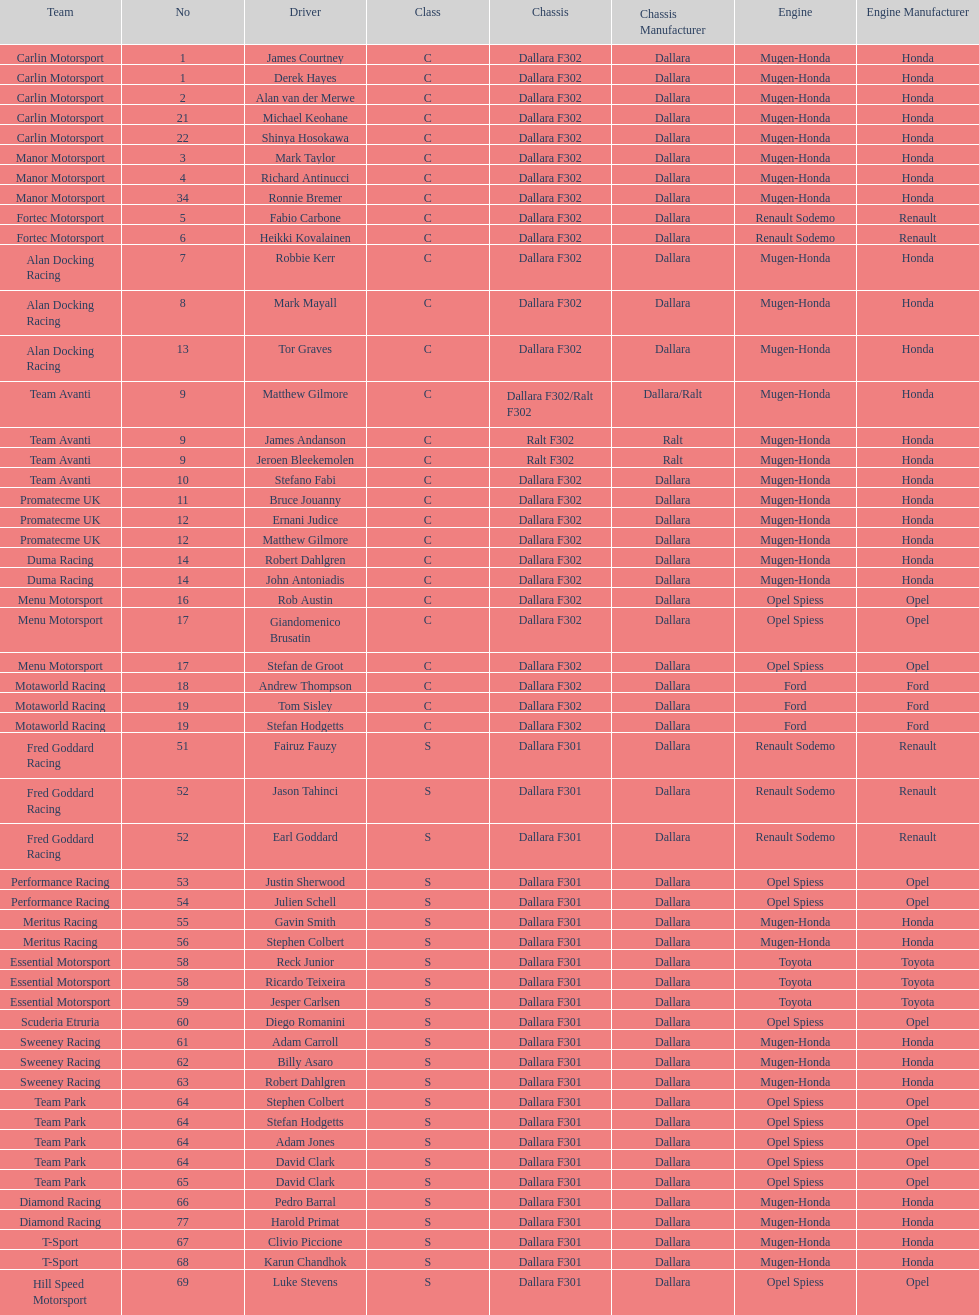What is the number of teams that had drivers all from the same country? 4. Would you mind parsing the complete table? {'header': ['Team', 'No', 'Driver', 'Class', 'Chassis', 'Chassis Manufacturer', 'Engine', 'Engine Manufacturer'], 'rows': [['Carlin Motorsport', '1', 'James Courtney', 'C', 'Dallara F302', 'Dallara', 'Mugen-Honda', 'Honda'], ['Carlin Motorsport', '1', 'Derek Hayes', 'C', 'Dallara F302', 'Dallara', 'Mugen-Honda', 'Honda'], ['Carlin Motorsport', '2', 'Alan van der Merwe', 'C', 'Dallara F302', 'Dallara', 'Mugen-Honda', 'Honda'], ['Carlin Motorsport', '21', 'Michael Keohane', 'C', 'Dallara F302', 'Dallara', 'Mugen-Honda', 'Honda'], ['Carlin Motorsport', '22', 'Shinya Hosokawa', 'C', 'Dallara F302', 'Dallara', 'Mugen-Honda', 'Honda'], ['Manor Motorsport', '3', 'Mark Taylor', 'C', 'Dallara F302', 'Dallara', 'Mugen-Honda', 'Honda'], ['Manor Motorsport', '4', 'Richard Antinucci', 'C', 'Dallara F302', 'Dallara', 'Mugen-Honda', 'Honda'], ['Manor Motorsport', '34', 'Ronnie Bremer', 'C', 'Dallara F302', 'Dallara', 'Mugen-Honda', 'Honda'], ['Fortec Motorsport', '5', 'Fabio Carbone', 'C', 'Dallara F302', 'Dallara', 'Renault Sodemo', 'Renault'], ['Fortec Motorsport', '6', 'Heikki Kovalainen', 'C', 'Dallara F302', 'Dallara', 'Renault Sodemo', 'Renault'], ['Alan Docking Racing', '7', 'Robbie Kerr', 'C', 'Dallara F302', 'Dallara', 'Mugen-Honda', 'Honda'], ['Alan Docking Racing', '8', 'Mark Mayall', 'C', 'Dallara F302', 'Dallara', 'Mugen-Honda', 'Honda'], ['Alan Docking Racing', '13', 'Tor Graves', 'C', 'Dallara F302', 'Dallara', 'Mugen-Honda', 'Honda'], ['Team Avanti', '9', 'Matthew Gilmore', 'C', 'Dallara F302/Ralt F302', 'Dallara/Ralt', 'Mugen-Honda', 'Honda'], ['Team Avanti', '9', 'James Andanson', 'C', 'Ralt F302', 'Ralt', 'Mugen-Honda', 'Honda'], ['Team Avanti', '9', 'Jeroen Bleekemolen', 'C', 'Ralt F302', 'Ralt', 'Mugen-Honda', 'Honda'], ['Team Avanti', '10', 'Stefano Fabi', 'C', 'Dallara F302', 'Dallara', 'Mugen-Honda', 'Honda'], ['Promatecme UK', '11', 'Bruce Jouanny', 'C', 'Dallara F302', 'Dallara', 'Mugen-Honda', 'Honda'], ['Promatecme UK', '12', 'Ernani Judice', 'C', 'Dallara F302', 'Dallara', 'Mugen-Honda', 'Honda'], ['Promatecme UK', '12', 'Matthew Gilmore', 'C', 'Dallara F302', 'Dallara', 'Mugen-Honda', 'Honda'], ['Duma Racing', '14', 'Robert Dahlgren', 'C', 'Dallara F302', 'Dallara', 'Mugen-Honda', 'Honda'], ['Duma Racing', '14', 'John Antoniadis', 'C', 'Dallara F302', 'Dallara', 'Mugen-Honda', 'Honda'], ['Menu Motorsport', '16', 'Rob Austin', 'C', 'Dallara F302', 'Dallara', 'Opel Spiess', 'Opel'], ['Menu Motorsport', '17', 'Giandomenico Brusatin', 'C', 'Dallara F302', 'Dallara', 'Opel Spiess', 'Opel'], ['Menu Motorsport', '17', 'Stefan de Groot', 'C', 'Dallara F302', 'Dallara', 'Opel Spiess', 'Opel'], ['Motaworld Racing', '18', 'Andrew Thompson', 'C', 'Dallara F302', 'Dallara', 'Ford', 'Ford'], ['Motaworld Racing', '19', 'Tom Sisley', 'C', 'Dallara F302', 'Dallara', 'Ford', 'Ford'], ['Motaworld Racing', '19', 'Stefan Hodgetts', 'C', 'Dallara F302', 'Dallara', 'Ford', 'Ford'], ['Fred Goddard Racing', '51', 'Fairuz Fauzy', 'S', 'Dallara F301', 'Dallara', 'Renault Sodemo', 'Renault'], ['Fred Goddard Racing', '52', 'Jason Tahinci', 'S', 'Dallara F301', 'Dallara', 'Renault Sodemo', 'Renault'], ['Fred Goddard Racing', '52', 'Earl Goddard', 'S', 'Dallara F301', 'Dallara', 'Renault Sodemo', 'Renault'], ['Performance Racing', '53', 'Justin Sherwood', 'S', 'Dallara F301', 'Dallara', 'Opel Spiess', 'Opel'], ['Performance Racing', '54', 'Julien Schell', 'S', 'Dallara F301', 'Dallara', 'Opel Spiess', 'Opel'], ['Meritus Racing', '55', 'Gavin Smith', 'S', 'Dallara F301', 'Dallara', 'Mugen-Honda', 'Honda'], ['Meritus Racing', '56', 'Stephen Colbert', 'S', 'Dallara F301', 'Dallara', 'Mugen-Honda', 'Honda'], ['Essential Motorsport', '58', 'Reck Junior', 'S', 'Dallara F301', 'Dallara', 'Toyota', 'Toyota'], ['Essential Motorsport', '58', 'Ricardo Teixeira', 'S', 'Dallara F301', 'Dallara', 'Toyota', 'Toyota'], ['Essential Motorsport', '59', 'Jesper Carlsen', 'S', 'Dallara F301', 'Dallara', 'Toyota', 'Toyota'], ['Scuderia Etruria', '60', 'Diego Romanini', 'S', 'Dallara F301', 'Dallara', 'Opel Spiess', 'Opel'], ['Sweeney Racing', '61', 'Adam Carroll', 'S', 'Dallara F301', 'Dallara', 'Mugen-Honda', 'Honda'], ['Sweeney Racing', '62', 'Billy Asaro', 'S', 'Dallara F301', 'Dallara', 'Mugen-Honda', 'Honda'], ['Sweeney Racing', '63', 'Robert Dahlgren', 'S', 'Dallara F301', 'Dallara', 'Mugen-Honda', 'Honda'], ['Team Park', '64', 'Stephen Colbert', 'S', 'Dallara F301', 'Dallara', 'Opel Spiess', 'Opel'], ['Team Park', '64', 'Stefan Hodgetts', 'S', 'Dallara F301', 'Dallara', 'Opel Spiess', 'Opel'], ['Team Park', '64', 'Adam Jones', 'S', 'Dallara F301', 'Dallara', 'Opel Spiess', 'Opel'], ['Team Park', '64', 'David Clark', 'S', 'Dallara F301', 'Dallara', 'Opel Spiess', 'Opel'], ['Team Park', '65', 'David Clark', 'S', 'Dallara F301', 'Dallara', 'Opel Spiess', 'Opel'], ['Diamond Racing', '66', 'Pedro Barral', 'S', 'Dallara F301', 'Dallara', 'Mugen-Honda', 'Honda'], ['Diamond Racing', '77', 'Harold Primat', 'S', 'Dallara F301', 'Dallara', 'Mugen-Honda', 'Honda'], ['T-Sport', '67', 'Clivio Piccione', 'S', 'Dallara F301', 'Dallara', 'Mugen-Honda', 'Honda'], ['T-Sport', '68', 'Karun Chandhok', 'S', 'Dallara F301', 'Dallara', 'Mugen-Honda', 'Honda'], ['Hill Speed Motorsport', '69', 'Luke Stevens', 'S', 'Dallara F301', 'Dallara', 'Opel Spiess', 'Opel']]} 